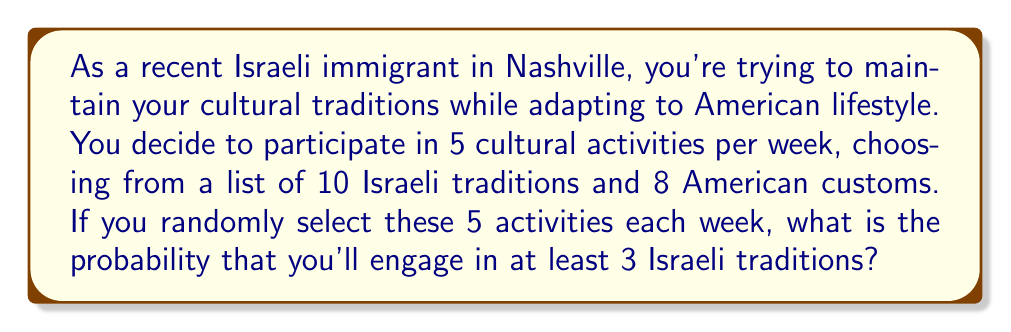Teach me how to tackle this problem. Let's approach this step-by-step:

1) First, we need to calculate the total number of ways to choose 5 activities from 18 options (10 Israeli + 8 American). This can be done using the combination formula:

   $$\binom{18}{5} = \frac{18!}{5!(18-5)!} = \frac{18!}{5!13!} = 8568$$

2) Now, we need to calculate the number of favorable outcomes. We can have:
   - 3 Israeli traditions and 2 American customs
   - 4 Israeli traditions and 1 American custom
   - 5 Israeli traditions and 0 American customs

3) Let's calculate each of these:

   a) 3 Israeli and 2 American:
      $$\binom{10}{3} \cdot \binom{8}{2} = 120 \cdot 28 = 3360$$

   b) 4 Israeli and 1 American:
      $$\binom{10}{4} \cdot \binom{8}{1} = 210 \cdot 8 = 1680$$

   c) 5 Israeli and 0 American:
      $$\binom{10}{5} \cdot \binom{8}{0} = 252 \cdot 1 = 252$$

4) The total number of favorable outcomes is:
   $$3360 + 1680 + 252 = 5292$$

5) The probability is then:

   $$P(\text{at least 3 Israeli}) = \frac{\text{favorable outcomes}}{\text{total outcomes}} = \frac{5292}{8568}$$

6) This fraction can be reduced:
   $$\frac{5292}{8568} = \frac{441}{714} \approx 0.6176$$
Answer: $\frac{441}{714}$ or approximately $0.6176$ or $61.76\%$ 